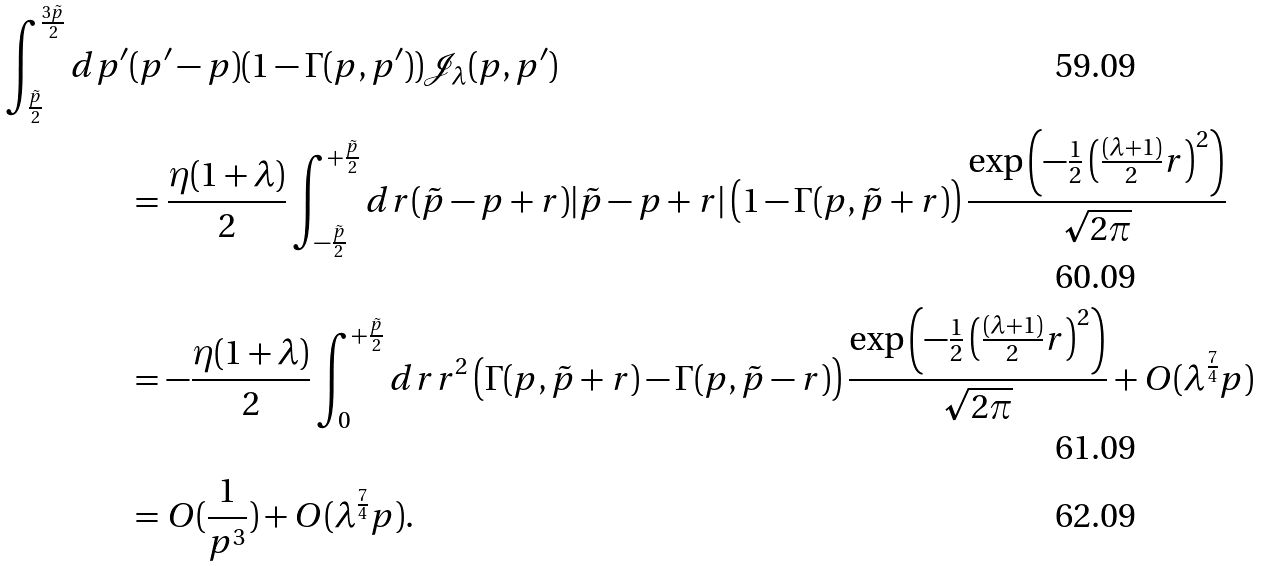Convert formula to latex. <formula><loc_0><loc_0><loc_500><loc_500>\int _ { \frac { \tilde { p } } { 2 } } ^ { \frac { 3 \tilde { p } } { 2 } } d p ^ { \prime } & ( p ^ { \prime } - p ) ( 1 - \Gamma ( p , p ^ { \prime } ) ) \mathcal { J } _ { \lambda } ( p , p ^ { \prime } ) \\ & = \frac { \eta ( 1 + \lambda ) } { 2 } \int _ { - \frac { \tilde { p } } { 2 } } ^ { + \frac { \tilde { p } } { 2 } } d r ( \tilde { p } - p + r ) | \tilde { p } - p + r | \left ( 1 - \Gamma ( p , \tilde { p } + r ) \right ) \frac { \exp \left ( - \frac { 1 } { 2 } \left ( \frac { ( \lambda + 1 ) } { 2 } r \right ) ^ { 2 } \right ) } { \sqrt { 2 \pi } } \\ & = - \frac { \eta ( 1 + \lambda ) } { 2 } \int _ { 0 } ^ { + \frac { \tilde { p } } { 2 } } d r r ^ { 2 } \left ( \Gamma ( p , \tilde { p } + r ) - \Gamma ( p , \tilde { p } - r ) \right ) \frac { \exp \left ( - \frac { 1 } { 2 } \left ( \frac { ( \lambda + 1 ) } { 2 } r \right ) ^ { 2 } \right ) } { \sqrt { 2 \pi } } + O ( \lambda ^ { \frac { 7 } { 4 } } p ) \\ & = O ( \frac { 1 } { p ^ { 3 } } ) + O ( \lambda ^ { \frac { 7 } { 4 } } p ) .</formula> 